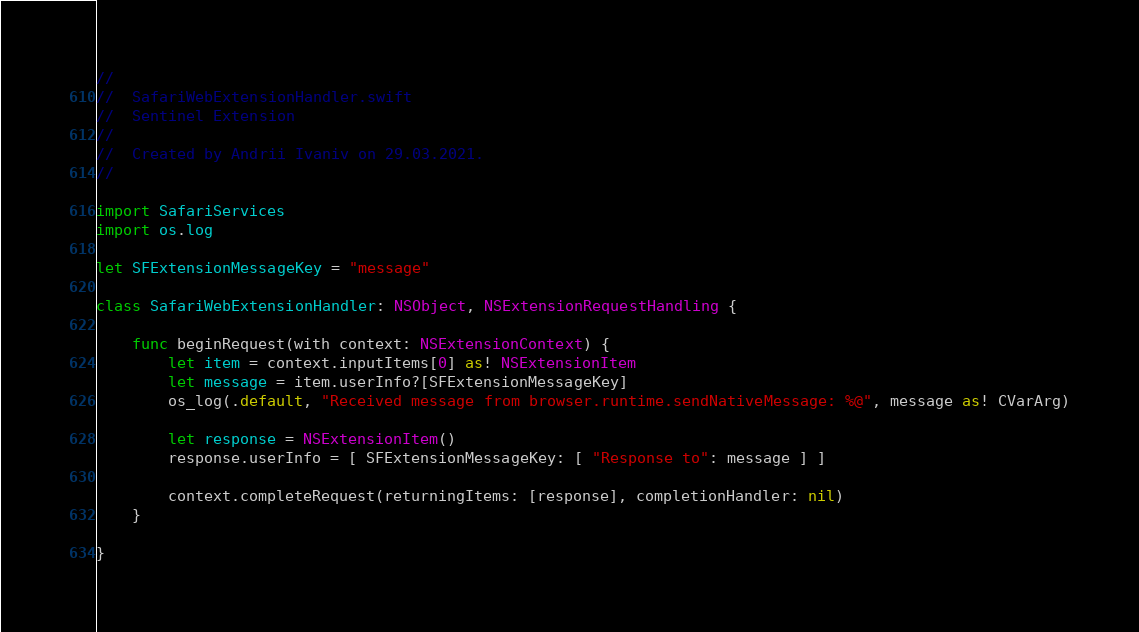Convert code to text. <code><loc_0><loc_0><loc_500><loc_500><_Swift_>//
//  SafariWebExtensionHandler.swift
//  Sentinel Extension
//
//  Created by Andrii Ivaniv on 29.03.2021.
//

import SafariServices
import os.log

let SFExtensionMessageKey = "message"

class SafariWebExtensionHandler: NSObject, NSExtensionRequestHandling {

	func beginRequest(with context: NSExtensionContext) {
        let item = context.inputItems[0] as! NSExtensionItem
        let message = item.userInfo?[SFExtensionMessageKey]
        os_log(.default, "Received message from browser.runtime.sendNativeMessage: %@", message as! CVarArg)

        let response = NSExtensionItem()
        response.userInfo = [ SFExtensionMessageKey: [ "Response to": message ] ]

        context.completeRequest(returningItems: [response], completionHandler: nil)
    }
    
}
</code> 